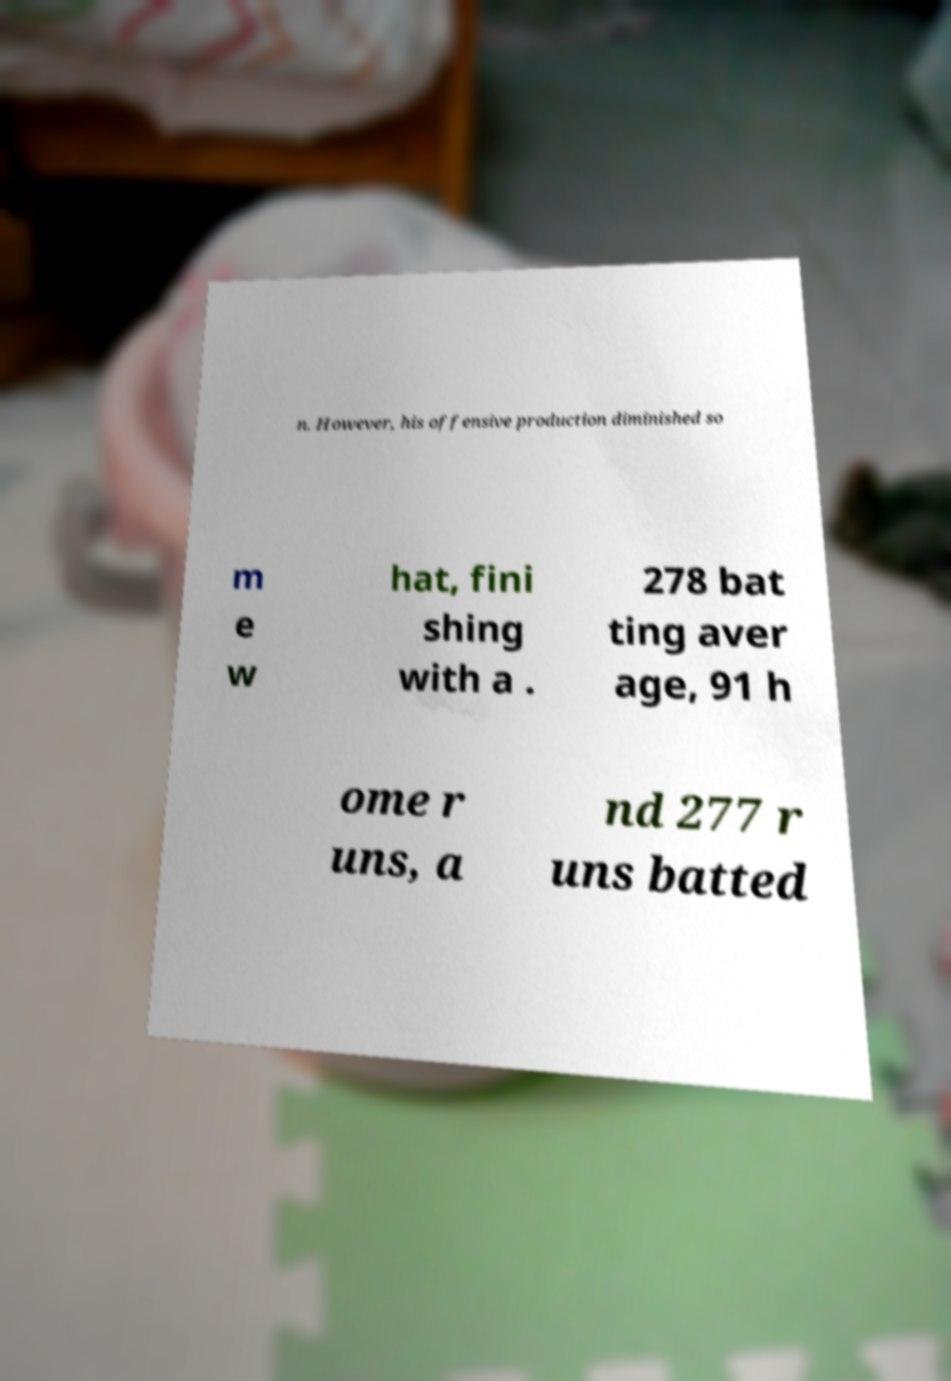Can you read and provide the text displayed in the image?This photo seems to have some interesting text. Can you extract and type it out for me? n. However, his offensive production diminished so m e w hat, fini shing with a . 278 bat ting aver age, 91 h ome r uns, a nd 277 r uns batted 